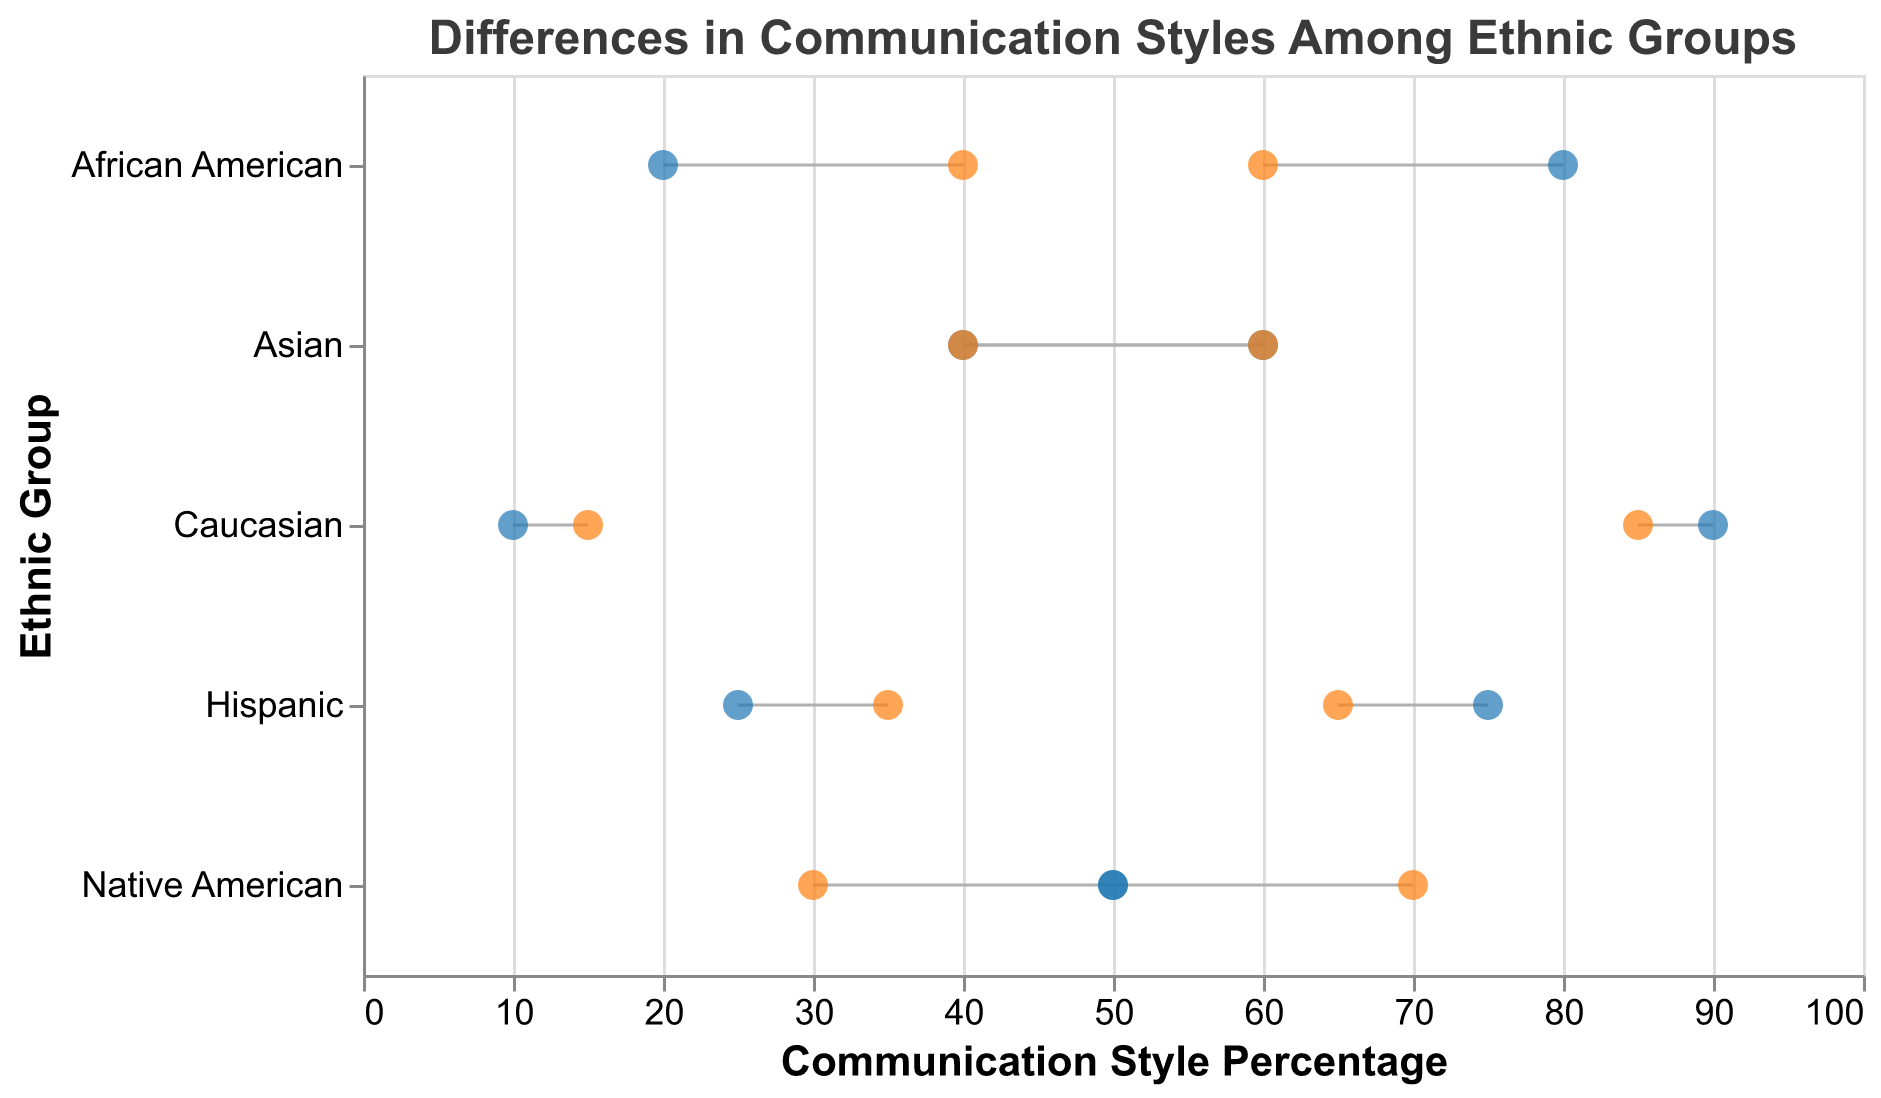What is the title of the plot? The title of the plot appears at the top center of the figure and describes the purpose of the visual.
Answer: Differences in Communication Styles Among Ethnic Groups Which ethnic group has the highest percentage of formal direct communication style? Look for the direct communication style across all ethnic groups and find the highest value in the "Formal" column.
Answer: Caucasian Which ethnic group has the largest difference between formal and informal indirect communication styles? Compare the difference between formal and informal percentages for indirect communication style across all ethnic groups. The largest difference is seen in the Native American group (50% formal vs. 70% informal).
Answer: Native American Which ethnic group shows an equal percentage for formal and informal communication styles in any category? Scan the datapoints to find where the percentages of formal and informal styles are equal.
Answer: Native American (Indirect) What is the average percentage of formal communication style for the Hispanic group? Add the formal percentages of direct and indirect communication styles (75% + 25%) and then divide by the number of styles (2).
Answer: 50% Compare the percentages of informal communication styles for African American and Asian groups. Which one is higher? Look up the informal communication percentages for both groups and compare them. African American has 60% and 40%, while Asian has 40% and 60%.
Answer: African American (Indirect), Asian (Direct) What is the median value of formal communication percentages for all ethnic groups? List all formal percentages (75, 25, 80, 20, 60, 40, 90, 10, 50, 50), sort them (10, 20, 25, 40, 50, 50, 60, 75, 80, 90), and find the median value, which is the middle value. As there are ten numbers, the median is the average of the 5th and 6th values.
Answer: 50 Which communication style (Direct or Indirect) has a higher average informal percentage across all ethnic groups? Calculate the average informal percentage for direct (65+60+40+85+30)/5 = 56 and indirect (35+40+60+15+70)/5 = 44. Compare the two averages to determine which is higher.
Answer: Direct Are there more instances of direct or indirect communication styles in the plot? Count how many entries belong to each communication style within the data points. There are 5 direct and 5 indirect instances.
Answer: Equal Which communication style shows the smallest variation between formal and informal percentages in the Caucasian group? Compare the formal and informal percentages for both direct (90-85) and indirect (10-15) communication styles within the Caucasian group. The variation is smaller in direct (5) than in indirect (5).
Answer: Direct 